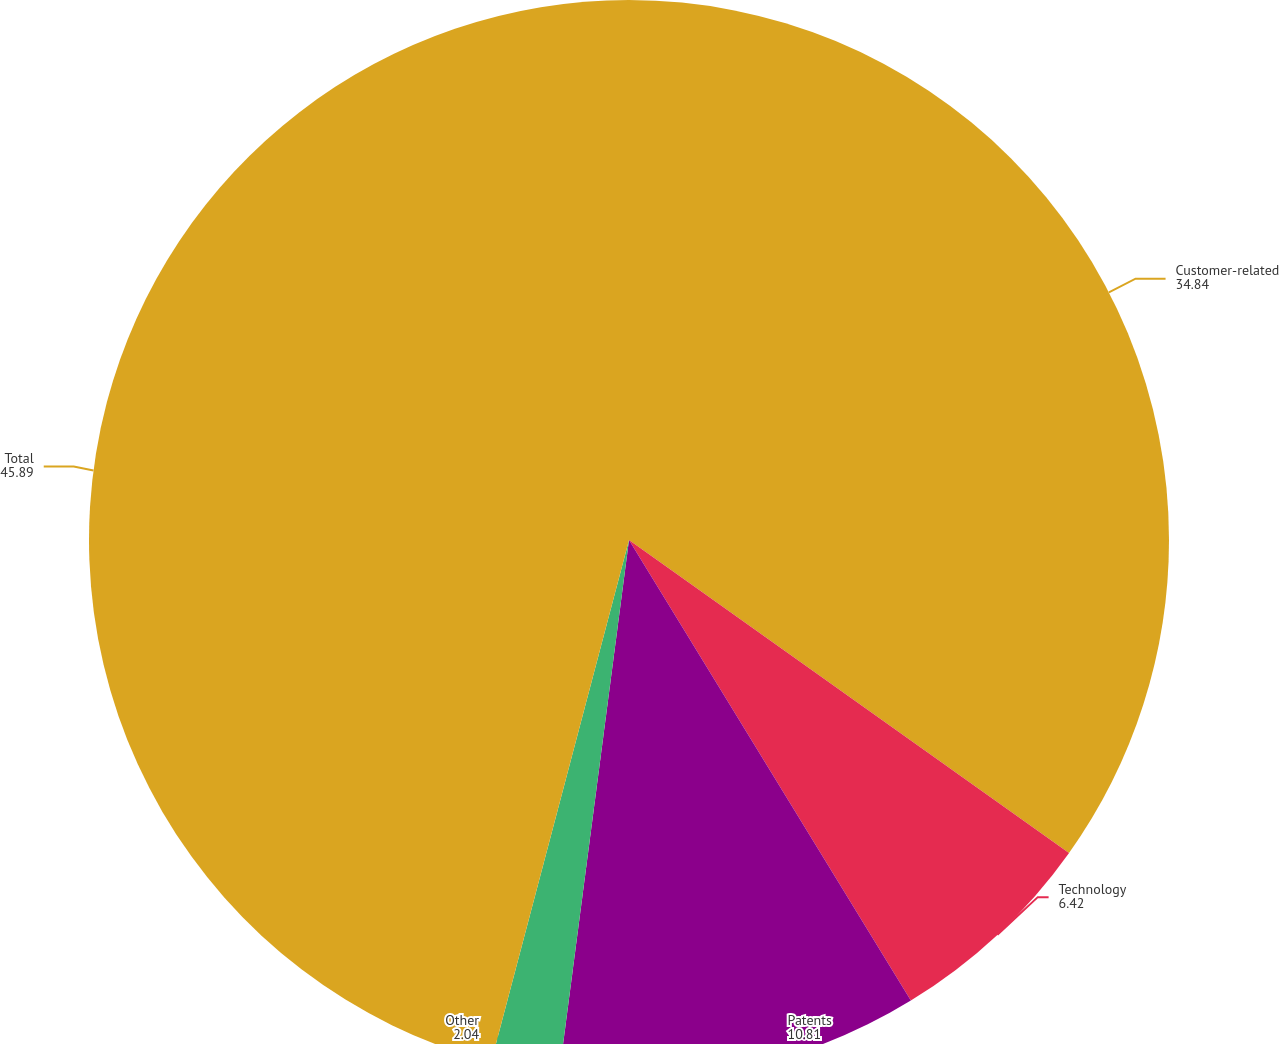Convert chart. <chart><loc_0><loc_0><loc_500><loc_500><pie_chart><fcel>Customer-related<fcel>Technology<fcel>Patents<fcel>Other<fcel>Total<nl><fcel>34.84%<fcel>6.42%<fcel>10.81%<fcel>2.04%<fcel>45.89%<nl></chart> 